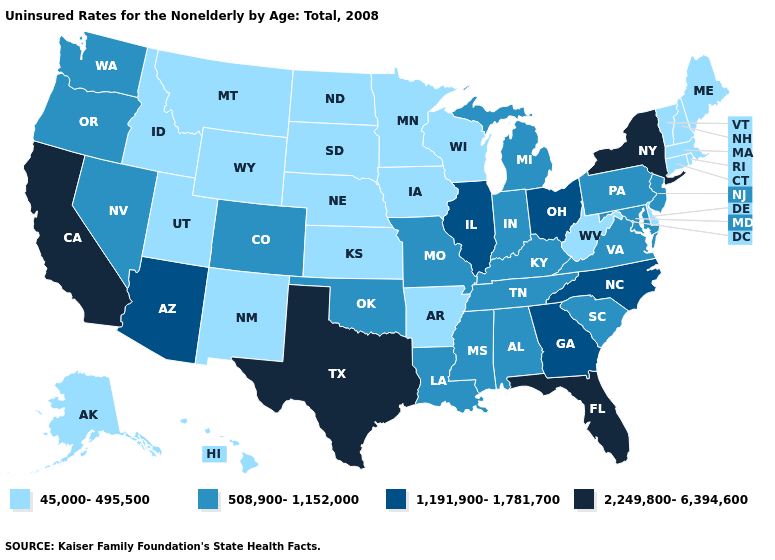What is the highest value in the USA?
Concise answer only. 2,249,800-6,394,600. Which states have the lowest value in the USA?
Short answer required. Alaska, Arkansas, Connecticut, Delaware, Hawaii, Idaho, Iowa, Kansas, Maine, Massachusetts, Minnesota, Montana, Nebraska, New Hampshire, New Mexico, North Dakota, Rhode Island, South Dakota, Utah, Vermont, West Virginia, Wisconsin, Wyoming. Name the states that have a value in the range 45,000-495,500?
Give a very brief answer. Alaska, Arkansas, Connecticut, Delaware, Hawaii, Idaho, Iowa, Kansas, Maine, Massachusetts, Minnesota, Montana, Nebraska, New Hampshire, New Mexico, North Dakota, Rhode Island, South Dakota, Utah, Vermont, West Virginia, Wisconsin, Wyoming. Name the states that have a value in the range 45,000-495,500?
Write a very short answer. Alaska, Arkansas, Connecticut, Delaware, Hawaii, Idaho, Iowa, Kansas, Maine, Massachusetts, Minnesota, Montana, Nebraska, New Hampshire, New Mexico, North Dakota, Rhode Island, South Dakota, Utah, Vermont, West Virginia, Wisconsin, Wyoming. What is the lowest value in the USA?
Concise answer only. 45,000-495,500. Name the states that have a value in the range 45,000-495,500?
Short answer required. Alaska, Arkansas, Connecticut, Delaware, Hawaii, Idaho, Iowa, Kansas, Maine, Massachusetts, Minnesota, Montana, Nebraska, New Hampshire, New Mexico, North Dakota, Rhode Island, South Dakota, Utah, Vermont, West Virginia, Wisconsin, Wyoming. Name the states that have a value in the range 2,249,800-6,394,600?
Write a very short answer. California, Florida, New York, Texas. Does Maryland have a lower value than Colorado?
Short answer required. No. What is the value of Rhode Island?
Give a very brief answer. 45,000-495,500. Among the states that border Missouri , does Nebraska have the highest value?
Quick response, please. No. Which states have the lowest value in the USA?
Short answer required. Alaska, Arkansas, Connecticut, Delaware, Hawaii, Idaho, Iowa, Kansas, Maine, Massachusetts, Minnesota, Montana, Nebraska, New Hampshire, New Mexico, North Dakota, Rhode Island, South Dakota, Utah, Vermont, West Virginia, Wisconsin, Wyoming. Name the states that have a value in the range 45,000-495,500?
Keep it brief. Alaska, Arkansas, Connecticut, Delaware, Hawaii, Idaho, Iowa, Kansas, Maine, Massachusetts, Minnesota, Montana, Nebraska, New Hampshire, New Mexico, North Dakota, Rhode Island, South Dakota, Utah, Vermont, West Virginia, Wisconsin, Wyoming. Name the states that have a value in the range 45,000-495,500?
Give a very brief answer. Alaska, Arkansas, Connecticut, Delaware, Hawaii, Idaho, Iowa, Kansas, Maine, Massachusetts, Minnesota, Montana, Nebraska, New Hampshire, New Mexico, North Dakota, Rhode Island, South Dakota, Utah, Vermont, West Virginia, Wisconsin, Wyoming. Which states have the lowest value in the Northeast?
Concise answer only. Connecticut, Maine, Massachusetts, New Hampshire, Rhode Island, Vermont. What is the value of Wisconsin?
Quick response, please. 45,000-495,500. 